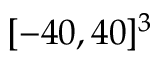Convert formula to latex. <formula><loc_0><loc_0><loc_500><loc_500>[ - 4 0 , 4 0 ] ^ { 3 }</formula> 